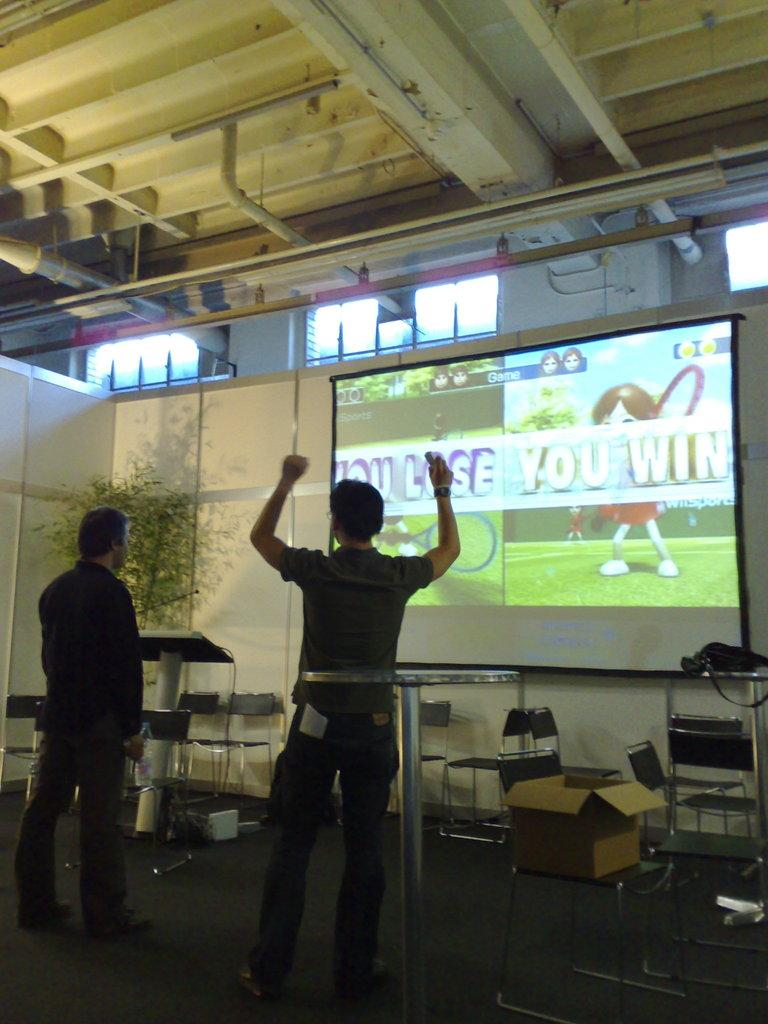<image>
Summarize the visual content of the image. The player who just won has his hands up in the air as the screen says "You Win." 